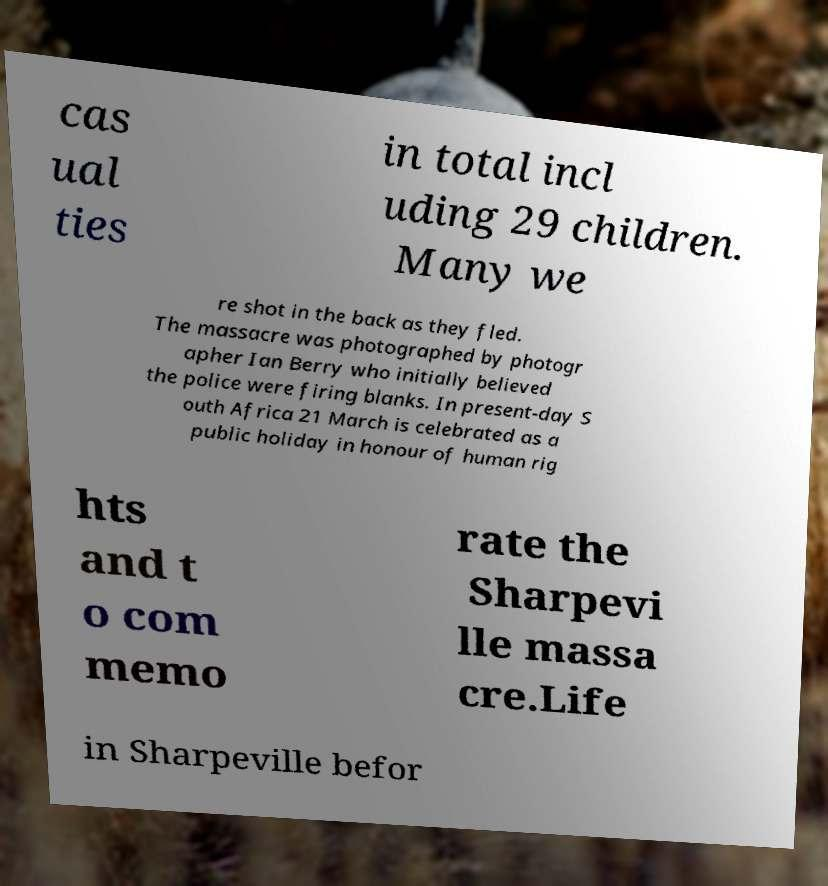There's text embedded in this image that I need extracted. Can you transcribe it verbatim? cas ual ties in total incl uding 29 children. Many we re shot in the back as they fled. The massacre was photographed by photogr apher Ian Berry who initially believed the police were firing blanks. In present-day S outh Africa 21 March is celebrated as a public holiday in honour of human rig hts and t o com memo rate the Sharpevi lle massa cre.Life in Sharpeville befor 